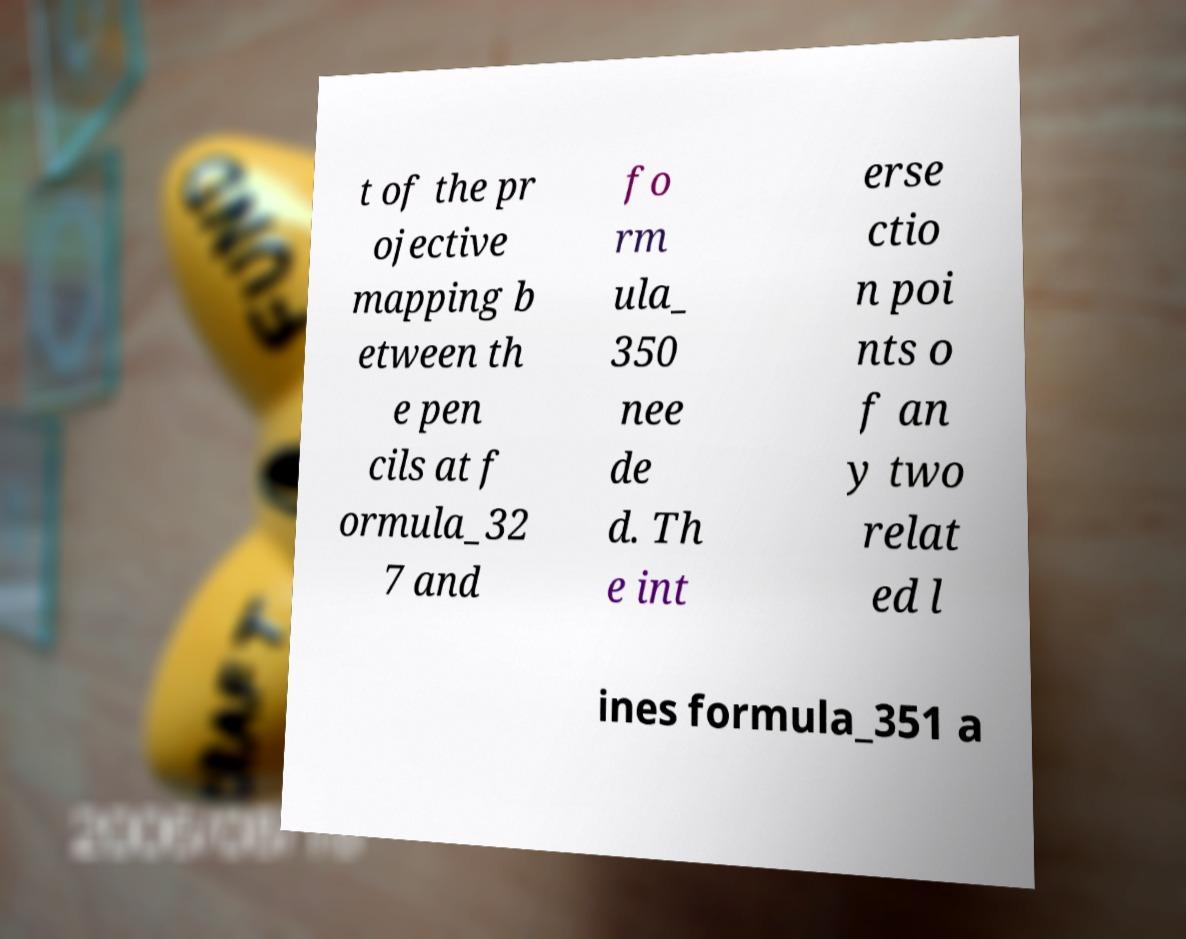What messages or text are displayed in this image? I need them in a readable, typed format. t of the pr ojective mapping b etween th e pen cils at f ormula_32 7 and fo rm ula_ 350 nee de d. Th e int erse ctio n poi nts o f an y two relat ed l ines formula_351 a 